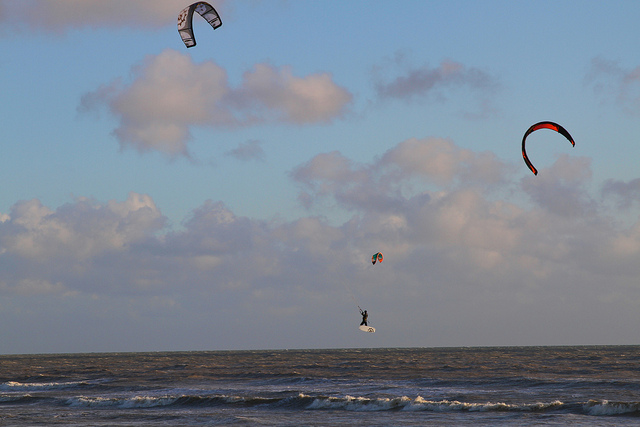Given the kites' positions and the surfer's movement, what can you infer about the wind direction? Observing the kites' orientations and their airborne trajectories, one could surmise that the wind whisking them aloft flows from the left side of the image. This inference is lent credence by the kite surfer's alignment, which seems attuned to capitalize on the propelling gusts from that direction. 